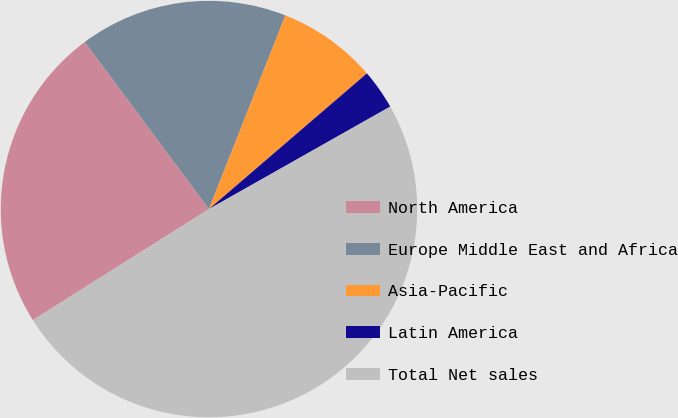Convert chart to OTSL. <chart><loc_0><loc_0><loc_500><loc_500><pie_chart><fcel>North America<fcel>Europe Middle East and Africa<fcel>Asia-Pacific<fcel>Latin America<fcel>Total Net sales<nl><fcel>23.78%<fcel>16.15%<fcel>7.72%<fcel>3.11%<fcel>49.23%<nl></chart> 